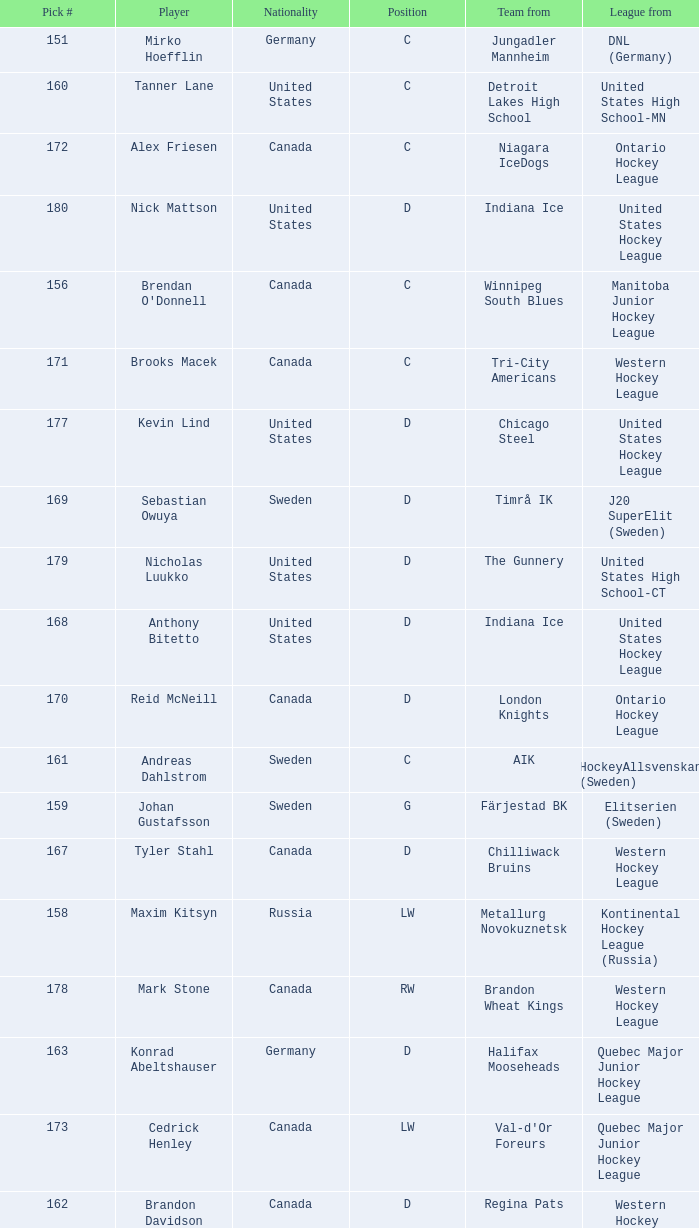What is the average pick # from the Quebec Major Junior Hockey League player Samuel Carrier? 176.0. 